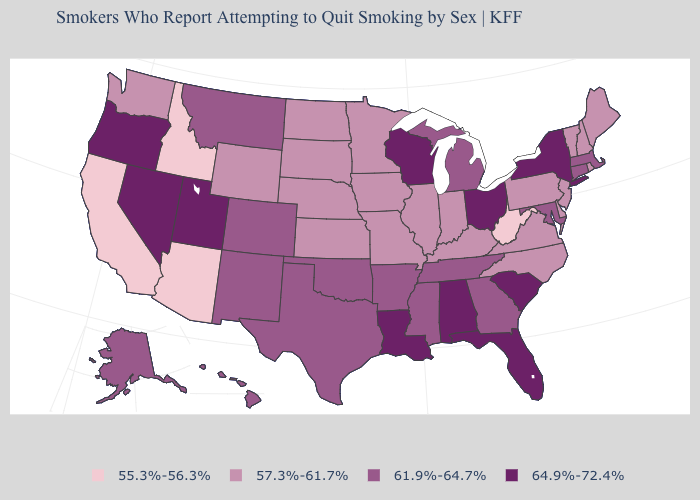What is the lowest value in the West?
Give a very brief answer. 55.3%-56.3%. What is the value of Oklahoma?
Answer briefly. 61.9%-64.7%. What is the value of North Dakota?
Short answer required. 57.3%-61.7%. Name the states that have a value in the range 64.9%-72.4%?
Write a very short answer. Alabama, Florida, Louisiana, Nevada, New York, Ohio, Oregon, South Carolina, Utah, Wisconsin. Name the states that have a value in the range 55.3%-56.3%?
Keep it brief. Arizona, California, Idaho, West Virginia. Name the states that have a value in the range 61.9%-64.7%?
Concise answer only. Alaska, Arkansas, Colorado, Connecticut, Georgia, Hawaii, Maryland, Massachusetts, Michigan, Mississippi, Montana, New Mexico, Oklahoma, Tennessee, Texas. Among the states that border Louisiana , which have the highest value?
Be succinct. Arkansas, Mississippi, Texas. Does the first symbol in the legend represent the smallest category?
Quick response, please. Yes. Name the states that have a value in the range 64.9%-72.4%?
Be succinct. Alabama, Florida, Louisiana, Nevada, New York, Ohio, Oregon, South Carolina, Utah, Wisconsin. Name the states that have a value in the range 57.3%-61.7%?
Short answer required. Delaware, Illinois, Indiana, Iowa, Kansas, Kentucky, Maine, Minnesota, Missouri, Nebraska, New Hampshire, New Jersey, North Carolina, North Dakota, Pennsylvania, Rhode Island, South Dakota, Vermont, Virginia, Washington, Wyoming. What is the value of Massachusetts?
Give a very brief answer. 61.9%-64.7%. Name the states that have a value in the range 57.3%-61.7%?
Write a very short answer. Delaware, Illinois, Indiana, Iowa, Kansas, Kentucky, Maine, Minnesota, Missouri, Nebraska, New Hampshire, New Jersey, North Carolina, North Dakota, Pennsylvania, Rhode Island, South Dakota, Vermont, Virginia, Washington, Wyoming. Does Mississippi have a higher value than Arkansas?
Write a very short answer. No. What is the highest value in states that border Rhode Island?
Short answer required. 61.9%-64.7%. Among the states that border North Carolina , does South Carolina have the lowest value?
Give a very brief answer. No. 